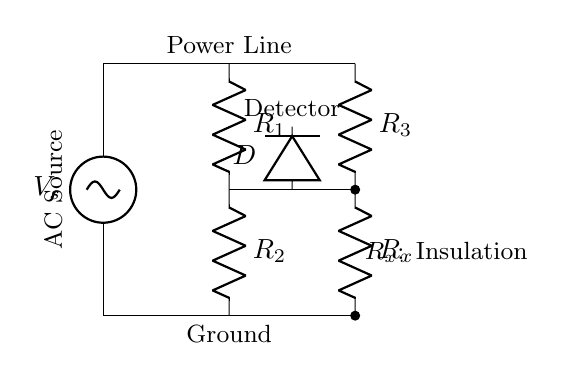What type of power source is used in the circuit? The circuit uses an AC source, as indicated by the labeling next to the voltage source. This means it operates with alternating current, which is essential for testing power line insulation.
Answer: AC source What components are present in the circuit? The circuit has a voltage source, three resistors (R1, R2, R3), a detector (D), and an insulation resistor (R_x). Each component plays a role in measuring the insulation properties of the power line.
Answer: Voltage source, three resistors, detector, insulation What is the role of R_x in this circuit? R_x represents the insulation resistance of the power line. Its value is tested against the other resistors to determine if the insulation is adequate for safe operation post-earthquake.
Answer: Insulation resistance How many resistors are connected in series? In the circuit, R1 and R2 are connected in series, while R3 and R_x are also in series with the other resistors, creating multiple series configurations. Hence, it totals two sets of resistors in series.
Answer: Two sets Why is the detector placed between R2 and R3? The detector is positioned to measure the voltage drop across R3, allowing for an assessment of the insulation resistance R_x. This placement is key for effective detection  of insulation faults.
Answer: To measure voltage drop What is the purpose of this AC bridge circuit? The AC bridge circuit is specifically designed to test the insulation of power lines by comparing the insulation resistance with known resistances, helping to assess safety and functionality after the earthquake.
Answer: Test insulation 